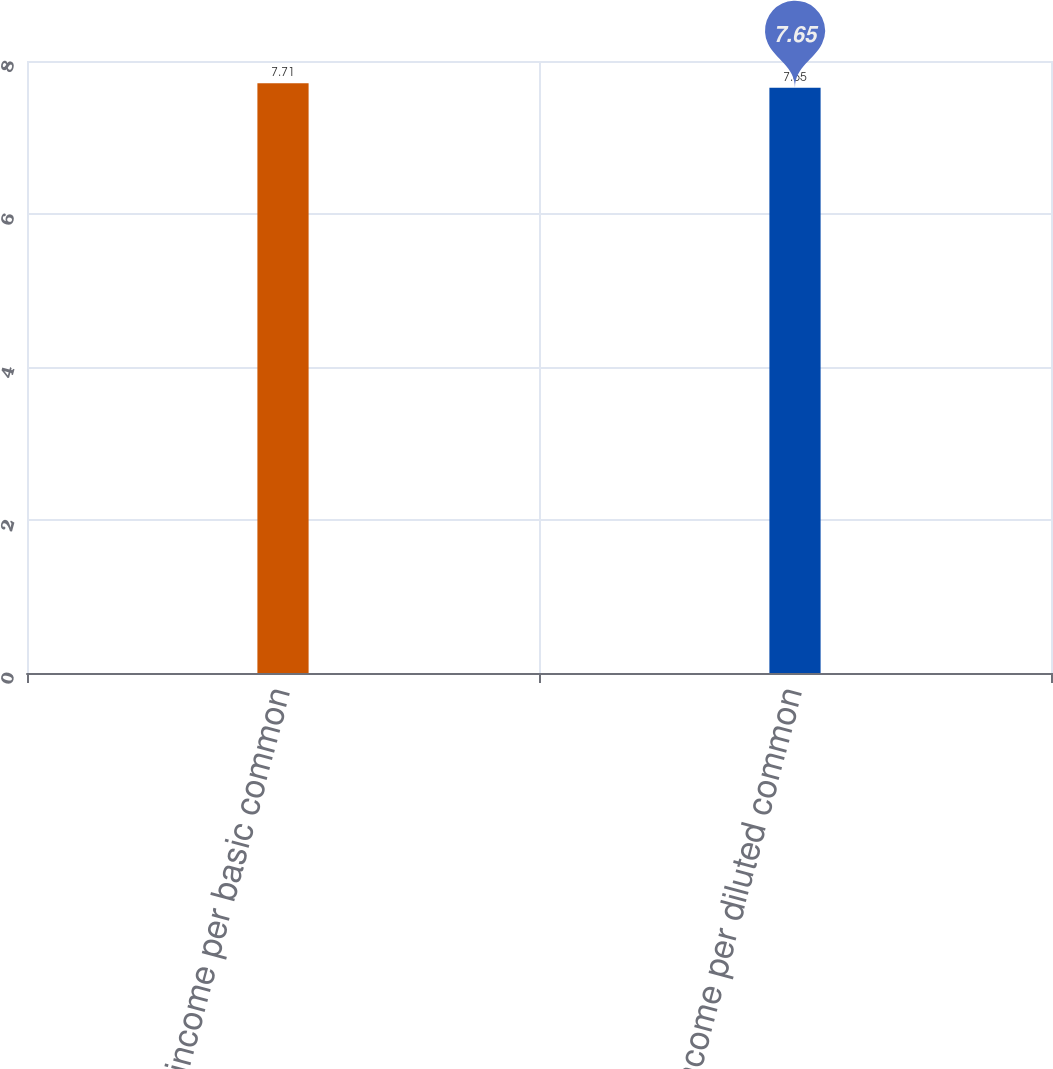Convert chart. <chart><loc_0><loc_0><loc_500><loc_500><bar_chart><fcel>Net income per basic common<fcel>Net income per diluted common<nl><fcel>7.71<fcel>7.65<nl></chart> 